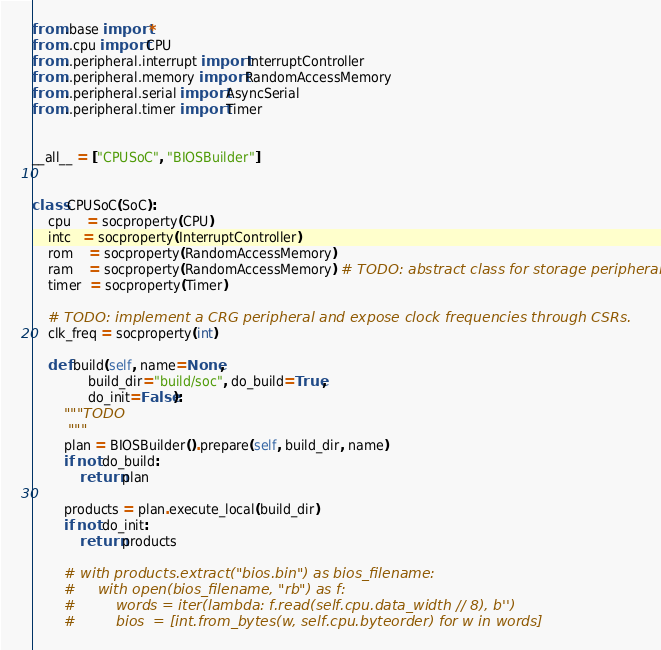Convert code to text. <code><loc_0><loc_0><loc_500><loc_500><_Python_>from .base import *
from ..cpu import CPU
from ..peripheral.interrupt import InterruptController
from ..peripheral.memory import RandomAccessMemory
from ..peripheral.serial import AsyncSerial
from ..peripheral.timer import Timer


__all__ = ["CPUSoC", "BIOSBuilder"]


class CPUSoC(SoC):
    cpu    = socproperty(CPU)
    intc   = socproperty(InterruptController)
    rom    = socproperty(RandomAccessMemory)
    ram    = socproperty(RandomAccessMemory) # TODO: abstract class for storage peripherals.
    timer  = socproperty(Timer)

    # TODO: implement a CRG peripheral and expose clock frequencies through CSRs.
    clk_freq = socproperty(int)

    def build(self, name=None,
              build_dir="build/soc", do_build=True,
              do_init=False):
        """TODO
        """
        plan = BIOSBuilder().prepare(self, build_dir, name)
        if not do_build:
            return plan

        products = plan.execute_local(build_dir)
        if not do_init:
            return products

        # with products.extract("bios.bin") as bios_filename:
        #     with open(bios_filename, "rb") as f:
        #         words = iter(lambda: f.read(self.cpu.data_width // 8), b'')
        #         bios  = [int.from_bytes(w, self.cpu.byteorder) for w in words]</code> 